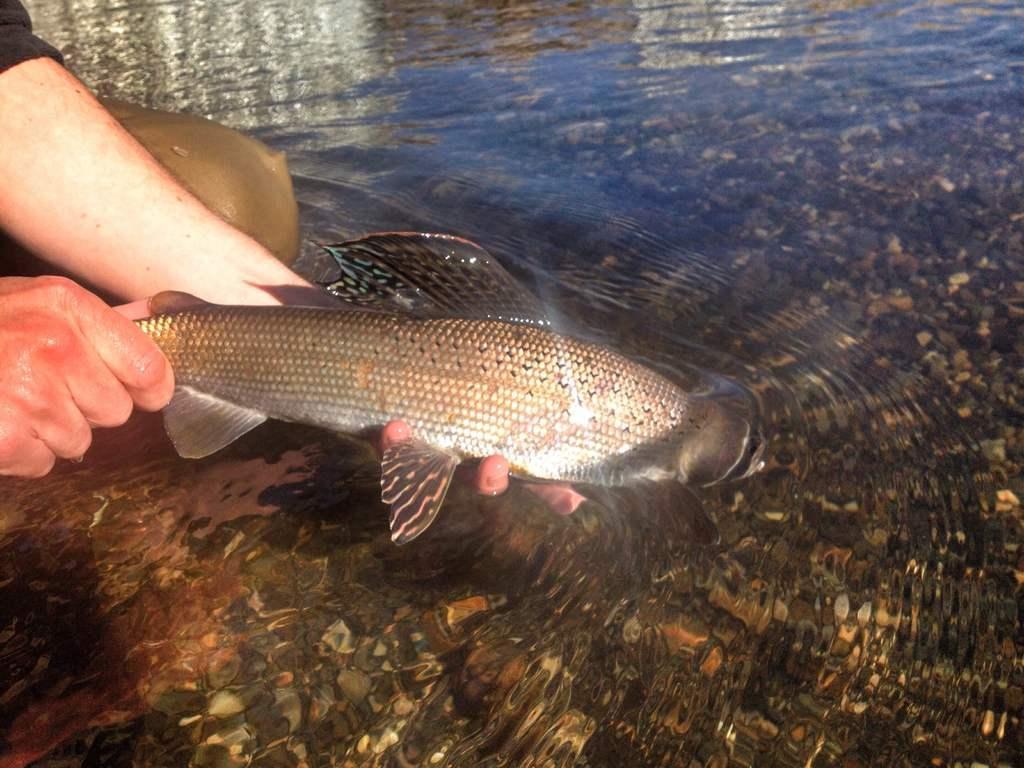In one or two sentences, can you explain what this image depicts? On the left side, there is a person holding a fish which is partially in the water. On the right side, there are stones and shells in the underground of this water. 